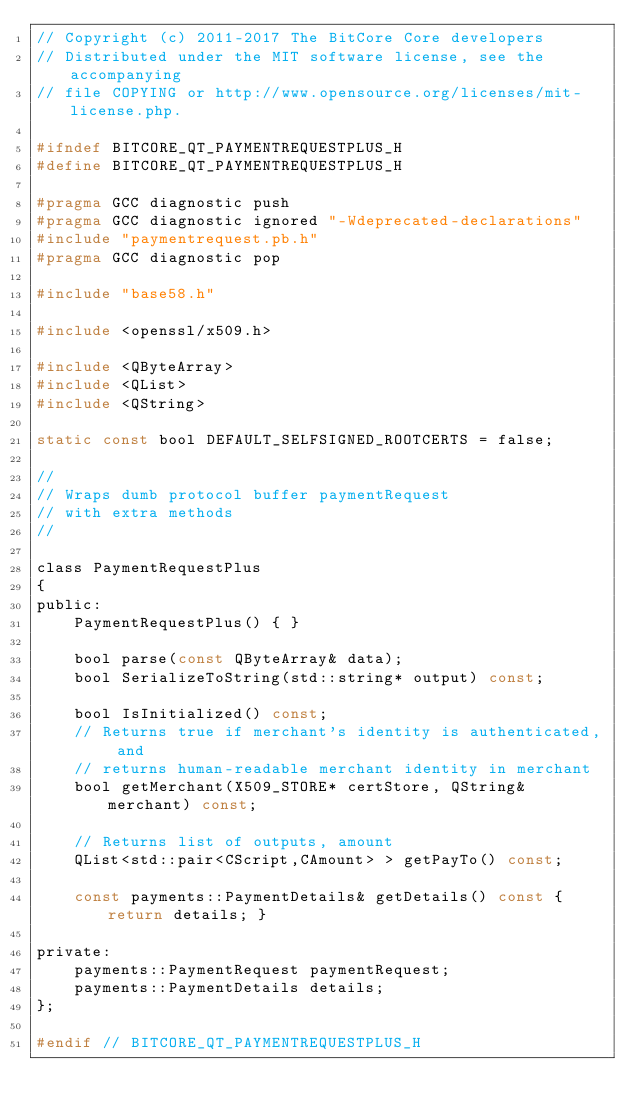Convert code to text. <code><loc_0><loc_0><loc_500><loc_500><_C_>// Copyright (c) 2011-2017 The BitCore Core developers
// Distributed under the MIT software license, see the accompanying
// file COPYING or http://www.opensource.org/licenses/mit-license.php.

#ifndef BITCORE_QT_PAYMENTREQUESTPLUS_H
#define BITCORE_QT_PAYMENTREQUESTPLUS_H

#pragma GCC diagnostic push
#pragma GCC diagnostic ignored "-Wdeprecated-declarations"
#include "paymentrequest.pb.h"
#pragma GCC diagnostic pop

#include "base58.h"

#include <openssl/x509.h>

#include <QByteArray>
#include <QList>
#include <QString>

static const bool DEFAULT_SELFSIGNED_ROOTCERTS = false;

//
// Wraps dumb protocol buffer paymentRequest
// with extra methods
//

class PaymentRequestPlus
{
public:
    PaymentRequestPlus() { }

    bool parse(const QByteArray& data);
    bool SerializeToString(std::string* output) const;

    bool IsInitialized() const;
    // Returns true if merchant's identity is authenticated, and
    // returns human-readable merchant identity in merchant
    bool getMerchant(X509_STORE* certStore, QString& merchant) const;

    // Returns list of outputs, amount
    QList<std::pair<CScript,CAmount> > getPayTo() const;

    const payments::PaymentDetails& getDetails() const { return details; }

private:
    payments::PaymentRequest paymentRequest;
    payments::PaymentDetails details;
};

#endif // BITCORE_QT_PAYMENTREQUESTPLUS_H
</code> 